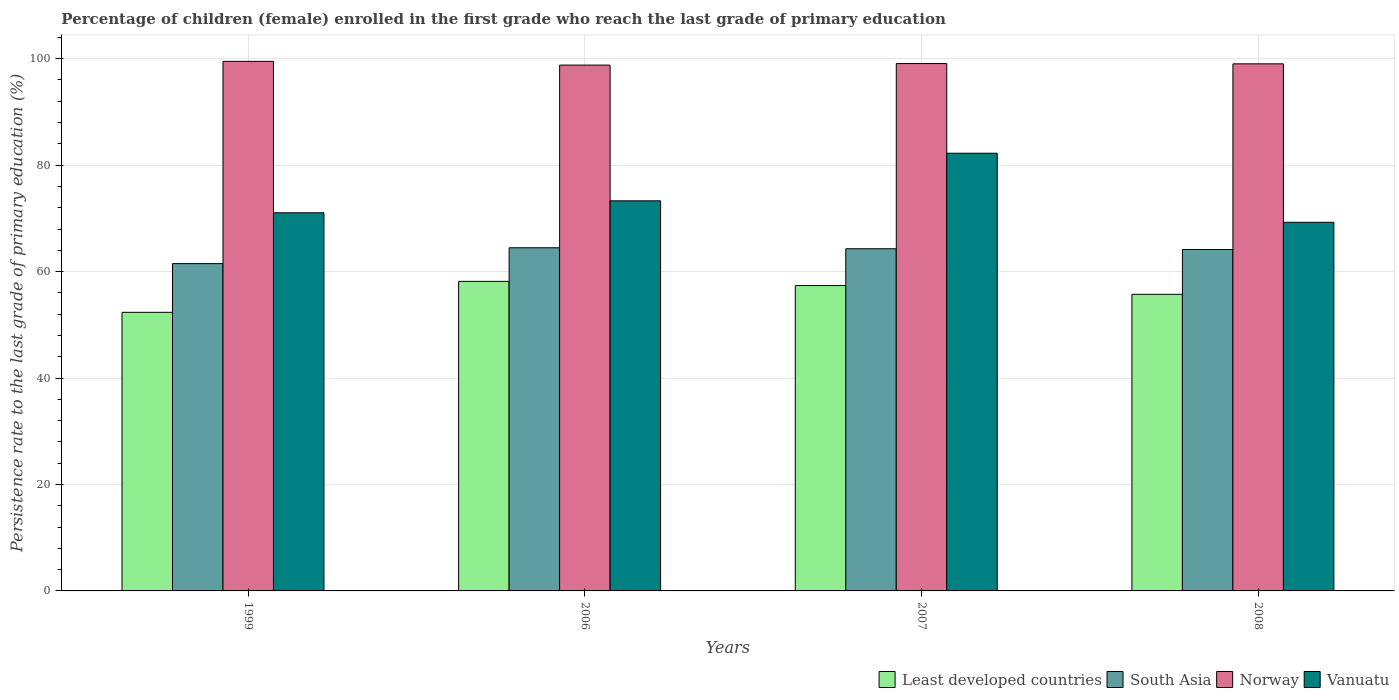How many different coloured bars are there?
Provide a short and direct response. 4. How many groups of bars are there?
Provide a short and direct response. 4. Are the number of bars per tick equal to the number of legend labels?
Give a very brief answer. Yes. Are the number of bars on each tick of the X-axis equal?
Provide a succinct answer. Yes. What is the label of the 4th group of bars from the left?
Give a very brief answer. 2008. In how many cases, is the number of bars for a given year not equal to the number of legend labels?
Give a very brief answer. 0. What is the persistence rate of children in Norway in 2006?
Make the answer very short. 98.8. Across all years, what is the maximum persistence rate of children in Norway?
Make the answer very short. 99.5. Across all years, what is the minimum persistence rate of children in Norway?
Provide a short and direct response. 98.8. What is the total persistence rate of children in Norway in the graph?
Your response must be concise. 396.41. What is the difference between the persistence rate of children in Norway in 2007 and that in 2008?
Offer a terse response. 0.05. What is the difference between the persistence rate of children in Norway in 2008 and the persistence rate of children in Least developed countries in 2007?
Give a very brief answer. 41.66. What is the average persistence rate of children in Least developed countries per year?
Offer a terse response. 55.9. In the year 2007, what is the difference between the persistence rate of children in Vanuatu and persistence rate of children in Least developed countries?
Your answer should be compact. 24.87. What is the ratio of the persistence rate of children in Vanuatu in 2006 to that in 2007?
Provide a short and direct response. 0.89. Is the persistence rate of children in Least developed countries in 1999 less than that in 2006?
Ensure brevity in your answer.  Yes. Is the difference between the persistence rate of children in Vanuatu in 1999 and 2008 greater than the difference between the persistence rate of children in Least developed countries in 1999 and 2008?
Give a very brief answer. Yes. What is the difference between the highest and the second highest persistence rate of children in Least developed countries?
Give a very brief answer. 0.79. What is the difference between the highest and the lowest persistence rate of children in Norway?
Your response must be concise. 0.7. In how many years, is the persistence rate of children in Vanuatu greater than the average persistence rate of children in Vanuatu taken over all years?
Offer a terse response. 1. Is the sum of the persistence rate of children in South Asia in 1999 and 2008 greater than the maximum persistence rate of children in Least developed countries across all years?
Provide a short and direct response. Yes. Is it the case that in every year, the sum of the persistence rate of children in Norway and persistence rate of children in South Asia is greater than the sum of persistence rate of children in Least developed countries and persistence rate of children in Vanuatu?
Make the answer very short. Yes. What does the 1st bar from the left in 1999 represents?
Your response must be concise. Least developed countries. What does the 4th bar from the right in 2007 represents?
Keep it short and to the point. Least developed countries. Is it the case that in every year, the sum of the persistence rate of children in South Asia and persistence rate of children in Least developed countries is greater than the persistence rate of children in Vanuatu?
Keep it short and to the point. Yes. Are all the bars in the graph horizontal?
Give a very brief answer. No. How many years are there in the graph?
Your answer should be very brief. 4. What is the difference between two consecutive major ticks on the Y-axis?
Give a very brief answer. 20. Does the graph contain any zero values?
Give a very brief answer. No. Does the graph contain grids?
Offer a terse response. Yes. Where does the legend appear in the graph?
Offer a very short reply. Bottom right. How are the legend labels stacked?
Ensure brevity in your answer.  Horizontal. What is the title of the graph?
Ensure brevity in your answer.  Percentage of children (female) enrolled in the first grade who reach the last grade of primary education. What is the label or title of the Y-axis?
Your response must be concise. Persistence rate to the last grade of primary education (%). What is the Persistence rate to the last grade of primary education (%) in Least developed countries in 1999?
Your response must be concise. 52.35. What is the Persistence rate to the last grade of primary education (%) of South Asia in 1999?
Provide a succinct answer. 61.5. What is the Persistence rate to the last grade of primary education (%) in Norway in 1999?
Offer a terse response. 99.5. What is the Persistence rate to the last grade of primary education (%) of Vanuatu in 1999?
Offer a very short reply. 71.05. What is the Persistence rate to the last grade of primary education (%) in Least developed countries in 2006?
Make the answer very short. 58.16. What is the Persistence rate to the last grade of primary education (%) in South Asia in 2006?
Your response must be concise. 64.47. What is the Persistence rate to the last grade of primary education (%) of Norway in 2006?
Offer a very short reply. 98.8. What is the Persistence rate to the last grade of primary education (%) of Vanuatu in 2006?
Your answer should be very brief. 73.29. What is the Persistence rate to the last grade of primary education (%) of Least developed countries in 2007?
Provide a short and direct response. 57.37. What is the Persistence rate to the last grade of primary education (%) in South Asia in 2007?
Your answer should be very brief. 64.29. What is the Persistence rate to the last grade of primary education (%) of Norway in 2007?
Your response must be concise. 99.09. What is the Persistence rate to the last grade of primary education (%) in Vanuatu in 2007?
Give a very brief answer. 82.24. What is the Persistence rate to the last grade of primary education (%) in Least developed countries in 2008?
Keep it short and to the point. 55.73. What is the Persistence rate to the last grade of primary education (%) of South Asia in 2008?
Your answer should be very brief. 64.15. What is the Persistence rate to the last grade of primary education (%) of Norway in 2008?
Offer a very short reply. 99.03. What is the Persistence rate to the last grade of primary education (%) of Vanuatu in 2008?
Your response must be concise. 69.26. Across all years, what is the maximum Persistence rate to the last grade of primary education (%) of Least developed countries?
Your response must be concise. 58.16. Across all years, what is the maximum Persistence rate to the last grade of primary education (%) of South Asia?
Your response must be concise. 64.47. Across all years, what is the maximum Persistence rate to the last grade of primary education (%) of Norway?
Provide a short and direct response. 99.5. Across all years, what is the maximum Persistence rate to the last grade of primary education (%) of Vanuatu?
Provide a short and direct response. 82.24. Across all years, what is the minimum Persistence rate to the last grade of primary education (%) in Least developed countries?
Make the answer very short. 52.35. Across all years, what is the minimum Persistence rate to the last grade of primary education (%) of South Asia?
Your answer should be very brief. 61.5. Across all years, what is the minimum Persistence rate to the last grade of primary education (%) of Norway?
Provide a short and direct response. 98.8. Across all years, what is the minimum Persistence rate to the last grade of primary education (%) in Vanuatu?
Provide a short and direct response. 69.26. What is the total Persistence rate to the last grade of primary education (%) of Least developed countries in the graph?
Offer a very short reply. 223.61. What is the total Persistence rate to the last grade of primary education (%) of South Asia in the graph?
Give a very brief answer. 254.41. What is the total Persistence rate to the last grade of primary education (%) of Norway in the graph?
Provide a short and direct response. 396.41. What is the total Persistence rate to the last grade of primary education (%) in Vanuatu in the graph?
Give a very brief answer. 295.84. What is the difference between the Persistence rate to the last grade of primary education (%) of Least developed countries in 1999 and that in 2006?
Your answer should be compact. -5.82. What is the difference between the Persistence rate to the last grade of primary education (%) of South Asia in 1999 and that in 2006?
Keep it short and to the point. -2.97. What is the difference between the Persistence rate to the last grade of primary education (%) of Norway in 1999 and that in 2006?
Make the answer very short. 0.7. What is the difference between the Persistence rate to the last grade of primary education (%) in Vanuatu in 1999 and that in 2006?
Ensure brevity in your answer.  -2.25. What is the difference between the Persistence rate to the last grade of primary education (%) in Least developed countries in 1999 and that in 2007?
Provide a short and direct response. -5.03. What is the difference between the Persistence rate to the last grade of primary education (%) of South Asia in 1999 and that in 2007?
Your response must be concise. -2.79. What is the difference between the Persistence rate to the last grade of primary education (%) in Norway in 1999 and that in 2007?
Provide a succinct answer. 0.41. What is the difference between the Persistence rate to the last grade of primary education (%) of Vanuatu in 1999 and that in 2007?
Provide a short and direct response. -11.19. What is the difference between the Persistence rate to the last grade of primary education (%) in Least developed countries in 1999 and that in 2008?
Give a very brief answer. -3.38. What is the difference between the Persistence rate to the last grade of primary education (%) in South Asia in 1999 and that in 2008?
Your answer should be very brief. -2.65. What is the difference between the Persistence rate to the last grade of primary education (%) in Norway in 1999 and that in 2008?
Offer a terse response. 0.47. What is the difference between the Persistence rate to the last grade of primary education (%) of Vanuatu in 1999 and that in 2008?
Offer a terse response. 1.79. What is the difference between the Persistence rate to the last grade of primary education (%) in Least developed countries in 2006 and that in 2007?
Make the answer very short. 0.79. What is the difference between the Persistence rate to the last grade of primary education (%) of South Asia in 2006 and that in 2007?
Your response must be concise. 0.18. What is the difference between the Persistence rate to the last grade of primary education (%) of Norway in 2006 and that in 2007?
Provide a short and direct response. -0.29. What is the difference between the Persistence rate to the last grade of primary education (%) in Vanuatu in 2006 and that in 2007?
Offer a very short reply. -8.94. What is the difference between the Persistence rate to the last grade of primary education (%) of Least developed countries in 2006 and that in 2008?
Offer a terse response. 2.43. What is the difference between the Persistence rate to the last grade of primary education (%) of South Asia in 2006 and that in 2008?
Ensure brevity in your answer.  0.32. What is the difference between the Persistence rate to the last grade of primary education (%) in Norway in 2006 and that in 2008?
Provide a succinct answer. -0.24. What is the difference between the Persistence rate to the last grade of primary education (%) in Vanuatu in 2006 and that in 2008?
Your response must be concise. 4.03. What is the difference between the Persistence rate to the last grade of primary education (%) in Least developed countries in 2007 and that in 2008?
Provide a succinct answer. 1.64. What is the difference between the Persistence rate to the last grade of primary education (%) of South Asia in 2007 and that in 2008?
Your answer should be compact. 0.14. What is the difference between the Persistence rate to the last grade of primary education (%) of Norway in 2007 and that in 2008?
Provide a short and direct response. 0.05. What is the difference between the Persistence rate to the last grade of primary education (%) of Vanuatu in 2007 and that in 2008?
Your response must be concise. 12.98. What is the difference between the Persistence rate to the last grade of primary education (%) in Least developed countries in 1999 and the Persistence rate to the last grade of primary education (%) in South Asia in 2006?
Your response must be concise. -12.13. What is the difference between the Persistence rate to the last grade of primary education (%) of Least developed countries in 1999 and the Persistence rate to the last grade of primary education (%) of Norway in 2006?
Provide a succinct answer. -46.45. What is the difference between the Persistence rate to the last grade of primary education (%) of Least developed countries in 1999 and the Persistence rate to the last grade of primary education (%) of Vanuatu in 2006?
Your response must be concise. -20.95. What is the difference between the Persistence rate to the last grade of primary education (%) in South Asia in 1999 and the Persistence rate to the last grade of primary education (%) in Norway in 2006?
Provide a short and direct response. -37.3. What is the difference between the Persistence rate to the last grade of primary education (%) of South Asia in 1999 and the Persistence rate to the last grade of primary education (%) of Vanuatu in 2006?
Keep it short and to the point. -11.8. What is the difference between the Persistence rate to the last grade of primary education (%) of Norway in 1999 and the Persistence rate to the last grade of primary education (%) of Vanuatu in 2006?
Offer a terse response. 26.2. What is the difference between the Persistence rate to the last grade of primary education (%) of Least developed countries in 1999 and the Persistence rate to the last grade of primary education (%) of South Asia in 2007?
Provide a short and direct response. -11.94. What is the difference between the Persistence rate to the last grade of primary education (%) in Least developed countries in 1999 and the Persistence rate to the last grade of primary education (%) in Norway in 2007?
Provide a short and direct response. -46.74. What is the difference between the Persistence rate to the last grade of primary education (%) of Least developed countries in 1999 and the Persistence rate to the last grade of primary education (%) of Vanuatu in 2007?
Provide a short and direct response. -29.89. What is the difference between the Persistence rate to the last grade of primary education (%) in South Asia in 1999 and the Persistence rate to the last grade of primary education (%) in Norway in 2007?
Provide a succinct answer. -37.59. What is the difference between the Persistence rate to the last grade of primary education (%) in South Asia in 1999 and the Persistence rate to the last grade of primary education (%) in Vanuatu in 2007?
Your answer should be compact. -20.74. What is the difference between the Persistence rate to the last grade of primary education (%) in Norway in 1999 and the Persistence rate to the last grade of primary education (%) in Vanuatu in 2007?
Offer a very short reply. 17.26. What is the difference between the Persistence rate to the last grade of primary education (%) of Least developed countries in 1999 and the Persistence rate to the last grade of primary education (%) of South Asia in 2008?
Make the answer very short. -11.8. What is the difference between the Persistence rate to the last grade of primary education (%) in Least developed countries in 1999 and the Persistence rate to the last grade of primary education (%) in Norway in 2008?
Provide a succinct answer. -46.69. What is the difference between the Persistence rate to the last grade of primary education (%) of Least developed countries in 1999 and the Persistence rate to the last grade of primary education (%) of Vanuatu in 2008?
Make the answer very short. -16.92. What is the difference between the Persistence rate to the last grade of primary education (%) in South Asia in 1999 and the Persistence rate to the last grade of primary education (%) in Norway in 2008?
Provide a succinct answer. -37.53. What is the difference between the Persistence rate to the last grade of primary education (%) of South Asia in 1999 and the Persistence rate to the last grade of primary education (%) of Vanuatu in 2008?
Offer a terse response. -7.76. What is the difference between the Persistence rate to the last grade of primary education (%) in Norway in 1999 and the Persistence rate to the last grade of primary education (%) in Vanuatu in 2008?
Provide a short and direct response. 30.24. What is the difference between the Persistence rate to the last grade of primary education (%) in Least developed countries in 2006 and the Persistence rate to the last grade of primary education (%) in South Asia in 2007?
Make the answer very short. -6.13. What is the difference between the Persistence rate to the last grade of primary education (%) in Least developed countries in 2006 and the Persistence rate to the last grade of primary education (%) in Norway in 2007?
Make the answer very short. -40.92. What is the difference between the Persistence rate to the last grade of primary education (%) in Least developed countries in 2006 and the Persistence rate to the last grade of primary education (%) in Vanuatu in 2007?
Your answer should be very brief. -24.07. What is the difference between the Persistence rate to the last grade of primary education (%) of South Asia in 2006 and the Persistence rate to the last grade of primary education (%) of Norway in 2007?
Your answer should be compact. -34.61. What is the difference between the Persistence rate to the last grade of primary education (%) in South Asia in 2006 and the Persistence rate to the last grade of primary education (%) in Vanuatu in 2007?
Offer a very short reply. -17.76. What is the difference between the Persistence rate to the last grade of primary education (%) of Norway in 2006 and the Persistence rate to the last grade of primary education (%) of Vanuatu in 2007?
Give a very brief answer. 16.56. What is the difference between the Persistence rate to the last grade of primary education (%) in Least developed countries in 2006 and the Persistence rate to the last grade of primary education (%) in South Asia in 2008?
Make the answer very short. -5.99. What is the difference between the Persistence rate to the last grade of primary education (%) in Least developed countries in 2006 and the Persistence rate to the last grade of primary education (%) in Norway in 2008?
Give a very brief answer. -40.87. What is the difference between the Persistence rate to the last grade of primary education (%) of Least developed countries in 2006 and the Persistence rate to the last grade of primary education (%) of Vanuatu in 2008?
Give a very brief answer. -11.1. What is the difference between the Persistence rate to the last grade of primary education (%) of South Asia in 2006 and the Persistence rate to the last grade of primary education (%) of Norway in 2008?
Offer a very short reply. -34.56. What is the difference between the Persistence rate to the last grade of primary education (%) of South Asia in 2006 and the Persistence rate to the last grade of primary education (%) of Vanuatu in 2008?
Offer a very short reply. -4.79. What is the difference between the Persistence rate to the last grade of primary education (%) of Norway in 2006 and the Persistence rate to the last grade of primary education (%) of Vanuatu in 2008?
Ensure brevity in your answer.  29.53. What is the difference between the Persistence rate to the last grade of primary education (%) in Least developed countries in 2007 and the Persistence rate to the last grade of primary education (%) in South Asia in 2008?
Provide a succinct answer. -6.78. What is the difference between the Persistence rate to the last grade of primary education (%) in Least developed countries in 2007 and the Persistence rate to the last grade of primary education (%) in Norway in 2008?
Your response must be concise. -41.66. What is the difference between the Persistence rate to the last grade of primary education (%) of Least developed countries in 2007 and the Persistence rate to the last grade of primary education (%) of Vanuatu in 2008?
Make the answer very short. -11.89. What is the difference between the Persistence rate to the last grade of primary education (%) of South Asia in 2007 and the Persistence rate to the last grade of primary education (%) of Norway in 2008?
Your response must be concise. -34.74. What is the difference between the Persistence rate to the last grade of primary education (%) in South Asia in 2007 and the Persistence rate to the last grade of primary education (%) in Vanuatu in 2008?
Your answer should be compact. -4.97. What is the difference between the Persistence rate to the last grade of primary education (%) in Norway in 2007 and the Persistence rate to the last grade of primary education (%) in Vanuatu in 2008?
Your answer should be very brief. 29.82. What is the average Persistence rate to the last grade of primary education (%) of Least developed countries per year?
Give a very brief answer. 55.9. What is the average Persistence rate to the last grade of primary education (%) of South Asia per year?
Give a very brief answer. 63.6. What is the average Persistence rate to the last grade of primary education (%) in Norway per year?
Offer a very short reply. 99.1. What is the average Persistence rate to the last grade of primary education (%) in Vanuatu per year?
Your answer should be very brief. 73.96. In the year 1999, what is the difference between the Persistence rate to the last grade of primary education (%) in Least developed countries and Persistence rate to the last grade of primary education (%) in South Asia?
Ensure brevity in your answer.  -9.15. In the year 1999, what is the difference between the Persistence rate to the last grade of primary education (%) of Least developed countries and Persistence rate to the last grade of primary education (%) of Norway?
Give a very brief answer. -47.15. In the year 1999, what is the difference between the Persistence rate to the last grade of primary education (%) of Least developed countries and Persistence rate to the last grade of primary education (%) of Vanuatu?
Offer a very short reply. -18.7. In the year 1999, what is the difference between the Persistence rate to the last grade of primary education (%) in South Asia and Persistence rate to the last grade of primary education (%) in Norway?
Provide a succinct answer. -38. In the year 1999, what is the difference between the Persistence rate to the last grade of primary education (%) of South Asia and Persistence rate to the last grade of primary education (%) of Vanuatu?
Your answer should be compact. -9.55. In the year 1999, what is the difference between the Persistence rate to the last grade of primary education (%) of Norway and Persistence rate to the last grade of primary education (%) of Vanuatu?
Provide a succinct answer. 28.45. In the year 2006, what is the difference between the Persistence rate to the last grade of primary education (%) in Least developed countries and Persistence rate to the last grade of primary education (%) in South Asia?
Make the answer very short. -6.31. In the year 2006, what is the difference between the Persistence rate to the last grade of primary education (%) of Least developed countries and Persistence rate to the last grade of primary education (%) of Norway?
Offer a very short reply. -40.63. In the year 2006, what is the difference between the Persistence rate to the last grade of primary education (%) in Least developed countries and Persistence rate to the last grade of primary education (%) in Vanuatu?
Give a very brief answer. -15.13. In the year 2006, what is the difference between the Persistence rate to the last grade of primary education (%) in South Asia and Persistence rate to the last grade of primary education (%) in Norway?
Your answer should be compact. -34.32. In the year 2006, what is the difference between the Persistence rate to the last grade of primary education (%) of South Asia and Persistence rate to the last grade of primary education (%) of Vanuatu?
Offer a terse response. -8.82. In the year 2006, what is the difference between the Persistence rate to the last grade of primary education (%) of Norway and Persistence rate to the last grade of primary education (%) of Vanuatu?
Give a very brief answer. 25.5. In the year 2007, what is the difference between the Persistence rate to the last grade of primary education (%) of Least developed countries and Persistence rate to the last grade of primary education (%) of South Asia?
Your answer should be compact. -6.92. In the year 2007, what is the difference between the Persistence rate to the last grade of primary education (%) of Least developed countries and Persistence rate to the last grade of primary education (%) of Norway?
Ensure brevity in your answer.  -41.71. In the year 2007, what is the difference between the Persistence rate to the last grade of primary education (%) in Least developed countries and Persistence rate to the last grade of primary education (%) in Vanuatu?
Make the answer very short. -24.86. In the year 2007, what is the difference between the Persistence rate to the last grade of primary education (%) of South Asia and Persistence rate to the last grade of primary education (%) of Norway?
Offer a very short reply. -34.8. In the year 2007, what is the difference between the Persistence rate to the last grade of primary education (%) of South Asia and Persistence rate to the last grade of primary education (%) of Vanuatu?
Offer a very short reply. -17.95. In the year 2007, what is the difference between the Persistence rate to the last grade of primary education (%) of Norway and Persistence rate to the last grade of primary education (%) of Vanuatu?
Offer a terse response. 16.85. In the year 2008, what is the difference between the Persistence rate to the last grade of primary education (%) of Least developed countries and Persistence rate to the last grade of primary education (%) of South Asia?
Make the answer very short. -8.42. In the year 2008, what is the difference between the Persistence rate to the last grade of primary education (%) in Least developed countries and Persistence rate to the last grade of primary education (%) in Norway?
Make the answer very short. -43.3. In the year 2008, what is the difference between the Persistence rate to the last grade of primary education (%) in Least developed countries and Persistence rate to the last grade of primary education (%) in Vanuatu?
Ensure brevity in your answer.  -13.53. In the year 2008, what is the difference between the Persistence rate to the last grade of primary education (%) in South Asia and Persistence rate to the last grade of primary education (%) in Norway?
Ensure brevity in your answer.  -34.88. In the year 2008, what is the difference between the Persistence rate to the last grade of primary education (%) of South Asia and Persistence rate to the last grade of primary education (%) of Vanuatu?
Your response must be concise. -5.11. In the year 2008, what is the difference between the Persistence rate to the last grade of primary education (%) in Norway and Persistence rate to the last grade of primary education (%) in Vanuatu?
Your response must be concise. 29.77. What is the ratio of the Persistence rate to the last grade of primary education (%) in Least developed countries in 1999 to that in 2006?
Make the answer very short. 0.9. What is the ratio of the Persistence rate to the last grade of primary education (%) of South Asia in 1999 to that in 2006?
Keep it short and to the point. 0.95. What is the ratio of the Persistence rate to the last grade of primary education (%) in Norway in 1999 to that in 2006?
Give a very brief answer. 1.01. What is the ratio of the Persistence rate to the last grade of primary education (%) of Vanuatu in 1999 to that in 2006?
Offer a very short reply. 0.97. What is the ratio of the Persistence rate to the last grade of primary education (%) in Least developed countries in 1999 to that in 2007?
Keep it short and to the point. 0.91. What is the ratio of the Persistence rate to the last grade of primary education (%) in South Asia in 1999 to that in 2007?
Keep it short and to the point. 0.96. What is the ratio of the Persistence rate to the last grade of primary education (%) of Vanuatu in 1999 to that in 2007?
Provide a succinct answer. 0.86. What is the ratio of the Persistence rate to the last grade of primary education (%) in Least developed countries in 1999 to that in 2008?
Ensure brevity in your answer.  0.94. What is the ratio of the Persistence rate to the last grade of primary education (%) in South Asia in 1999 to that in 2008?
Your answer should be very brief. 0.96. What is the ratio of the Persistence rate to the last grade of primary education (%) of Norway in 1999 to that in 2008?
Keep it short and to the point. 1. What is the ratio of the Persistence rate to the last grade of primary education (%) of Vanuatu in 1999 to that in 2008?
Your answer should be very brief. 1.03. What is the ratio of the Persistence rate to the last grade of primary education (%) of Least developed countries in 2006 to that in 2007?
Your answer should be very brief. 1.01. What is the ratio of the Persistence rate to the last grade of primary education (%) in Norway in 2006 to that in 2007?
Your answer should be very brief. 1. What is the ratio of the Persistence rate to the last grade of primary education (%) in Vanuatu in 2006 to that in 2007?
Offer a terse response. 0.89. What is the ratio of the Persistence rate to the last grade of primary education (%) in Least developed countries in 2006 to that in 2008?
Your answer should be compact. 1.04. What is the ratio of the Persistence rate to the last grade of primary education (%) of South Asia in 2006 to that in 2008?
Ensure brevity in your answer.  1. What is the ratio of the Persistence rate to the last grade of primary education (%) of Vanuatu in 2006 to that in 2008?
Make the answer very short. 1.06. What is the ratio of the Persistence rate to the last grade of primary education (%) in Least developed countries in 2007 to that in 2008?
Your answer should be very brief. 1.03. What is the ratio of the Persistence rate to the last grade of primary education (%) in South Asia in 2007 to that in 2008?
Offer a very short reply. 1. What is the ratio of the Persistence rate to the last grade of primary education (%) of Vanuatu in 2007 to that in 2008?
Provide a succinct answer. 1.19. What is the difference between the highest and the second highest Persistence rate to the last grade of primary education (%) of Least developed countries?
Your answer should be compact. 0.79. What is the difference between the highest and the second highest Persistence rate to the last grade of primary education (%) of South Asia?
Offer a terse response. 0.18. What is the difference between the highest and the second highest Persistence rate to the last grade of primary education (%) in Norway?
Keep it short and to the point. 0.41. What is the difference between the highest and the second highest Persistence rate to the last grade of primary education (%) of Vanuatu?
Your answer should be very brief. 8.94. What is the difference between the highest and the lowest Persistence rate to the last grade of primary education (%) of Least developed countries?
Your response must be concise. 5.82. What is the difference between the highest and the lowest Persistence rate to the last grade of primary education (%) in South Asia?
Provide a succinct answer. 2.97. What is the difference between the highest and the lowest Persistence rate to the last grade of primary education (%) of Norway?
Make the answer very short. 0.7. What is the difference between the highest and the lowest Persistence rate to the last grade of primary education (%) in Vanuatu?
Your response must be concise. 12.98. 